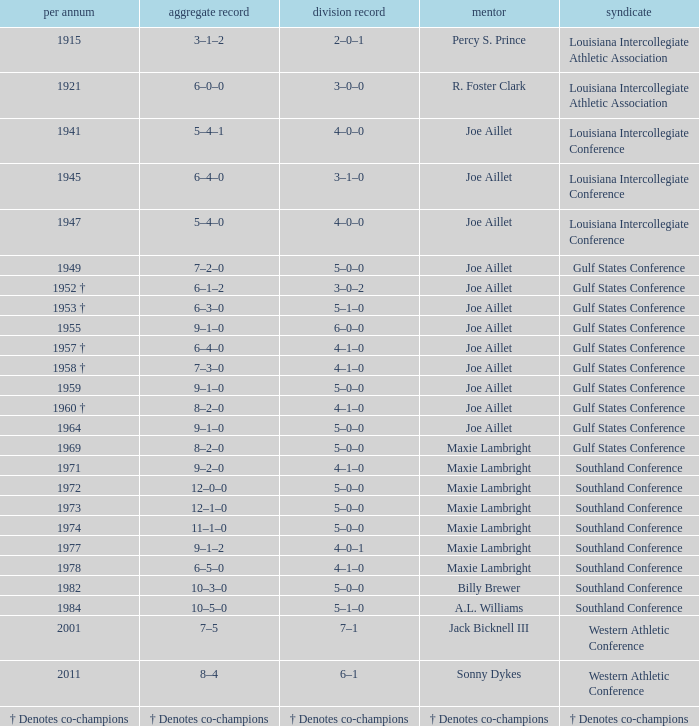What is the conference record for the year of 1971? 4–1–0. 